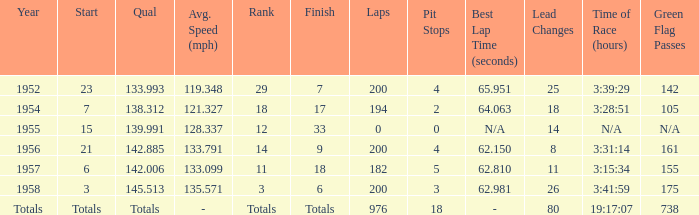What place did Jimmy Reece start from when he ranked 12? 15.0. 